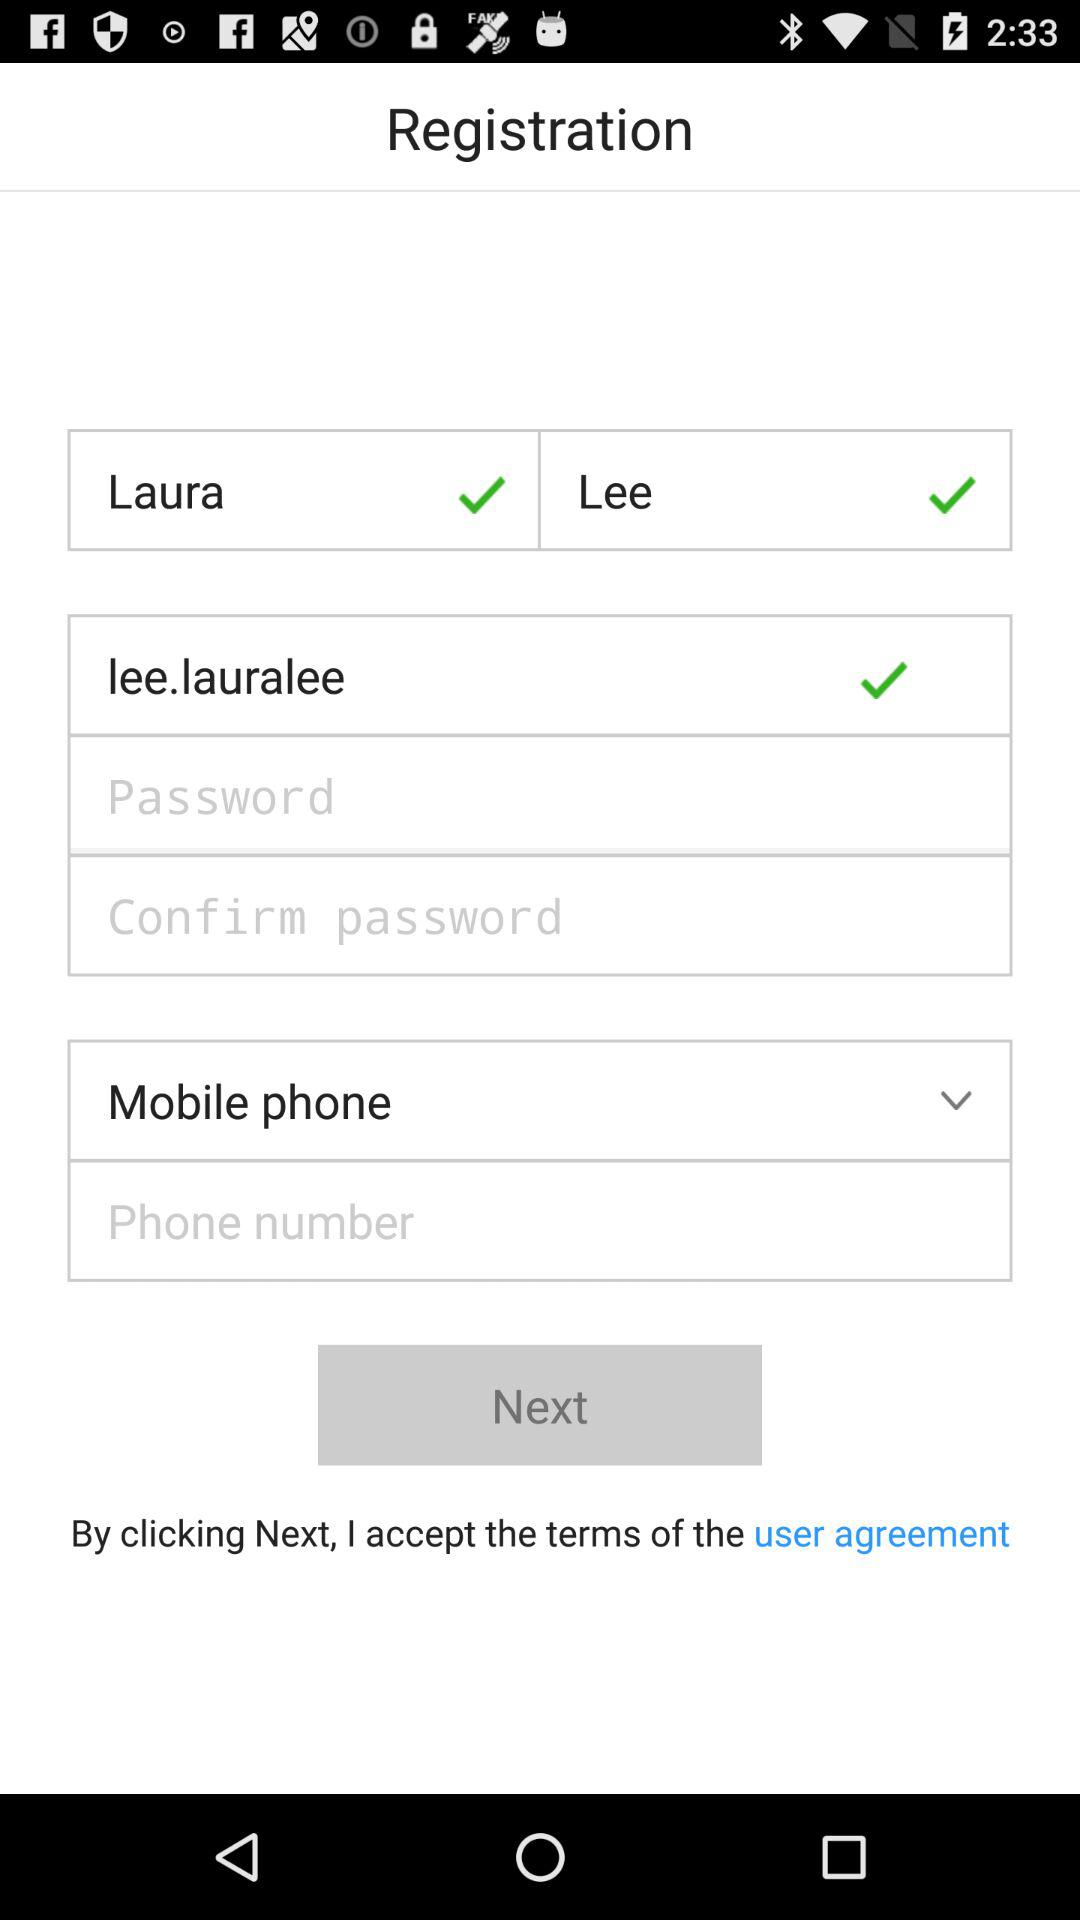What is the last name of the person? The last name of the person is Lee. 